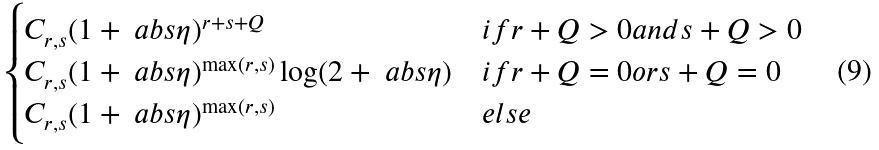<formula> <loc_0><loc_0><loc_500><loc_500>\begin{cases} C _ { r , s } ( 1 + \ a b s { \eta } ) ^ { r + s + Q } & i f r + Q > 0 a n d s + Q > 0 \\ C _ { r , s } ( 1 + \ a b s { \eta } ) ^ { \max ( r , s ) } \log ( 2 + \ a b s { \eta } ) & i f r + Q = 0 o r s + Q = 0 \\ C _ { r , s } ( 1 + \ a b s { \eta } ) ^ { \max ( r , s ) } & e l s e \end{cases}</formula> 